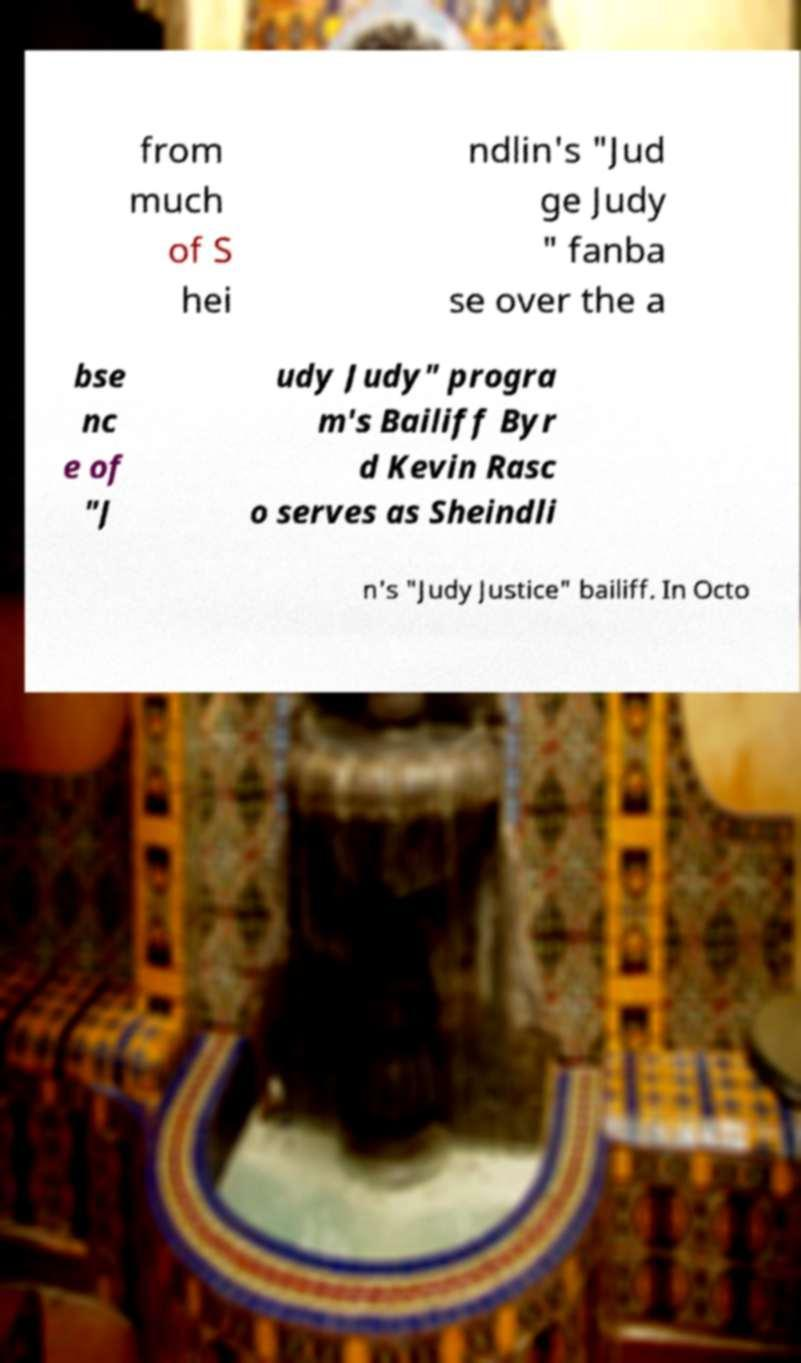What messages or text are displayed in this image? I need them in a readable, typed format. from much of S hei ndlin's "Jud ge Judy " fanba se over the a bse nc e of "J udy Judy" progra m's Bailiff Byr d Kevin Rasc o serves as Sheindli n's "Judy Justice" bailiff. In Octo 